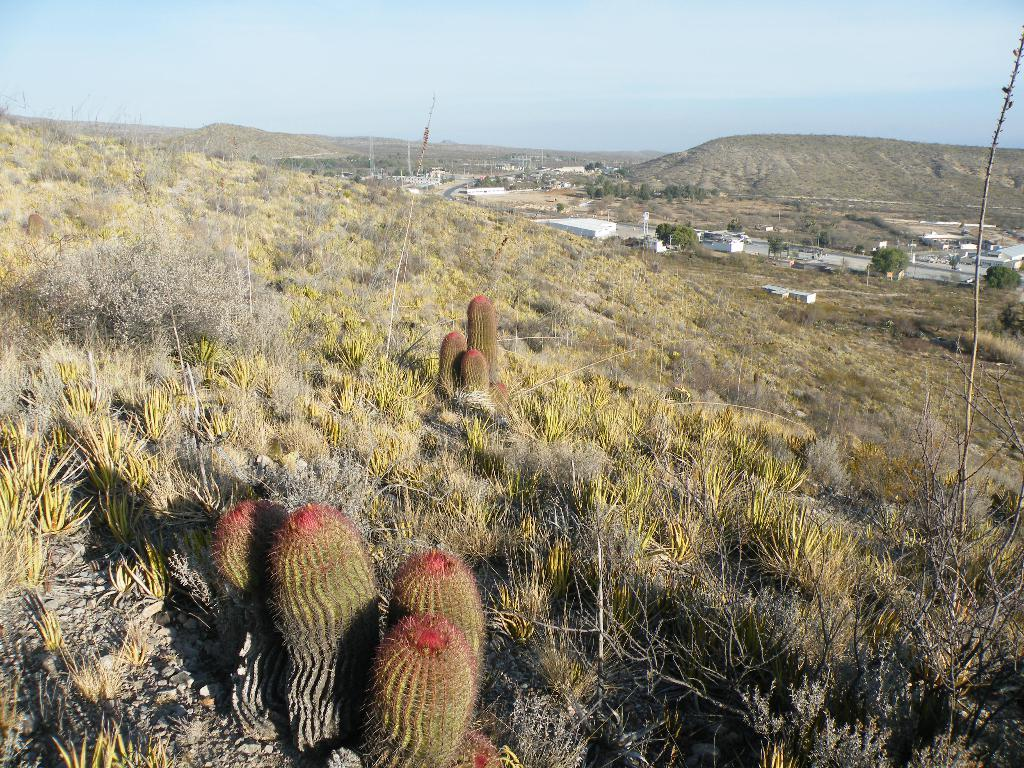What type of vegetation is present in the image? There are plants and grass in the image. What is the ground surface like in the image? The ground surface is covered with grass. What can be seen in the background of the image? There are buildings, poles, grass on a hill, and clouds in the sky in the background of the image. What type of mask is being worn by the plant in the image? There are no masks present in the image, as it features plants and grass. 